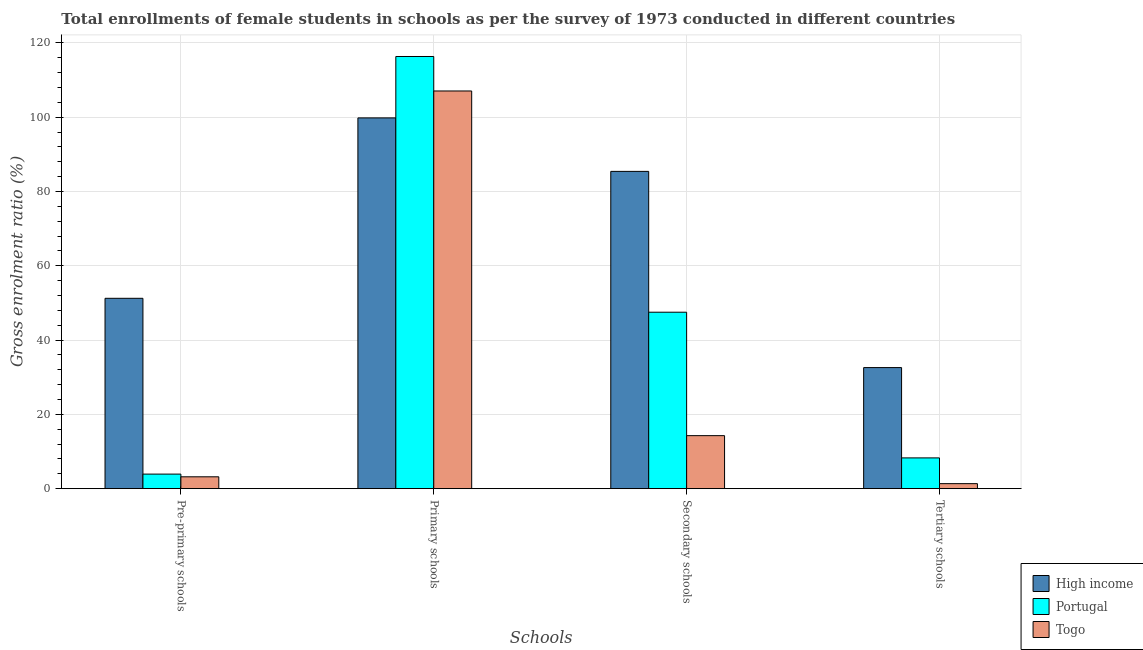How many different coloured bars are there?
Offer a very short reply. 3. Are the number of bars per tick equal to the number of legend labels?
Provide a short and direct response. Yes. Are the number of bars on each tick of the X-axis equal?
Your response must be concise. Yes. How many bars are there on the 2nd tick from the right?
Give a very brief answer. 3. What is the label of the 3rd group of bars from the left?
Ensure brevity in your answer.  Secondary schools. What is the gross enrolment ratio(female) in primary schools in High income?
Ensure brevity in your answer.  99.82. Across all countries, what is the maximum gross enrolment ratio(female) in secondary schools?
Your response must be concise. 85.42. Across all countries, what is the minimum gross enrolment ratio(female) in primary schools?
Your answer should be compact. 99.82. In which country was the gross enrolment ratio(female) in secondary schools maximum?
Offer a terse response. High income. In which country was the gross enrolment ratio(female) in secondary schools minimum?
Offer a terse response. Togo. What is the total gross enrolment ratio(female) in primary schools in the graph?
Your response must be concise. 323.25. What is the difference between the gross enrolment ratio(female) in tertiary schools in High income and that in Portugal?
Your answer should be very brief. 24.32. What is the difference between the gross enrolment ratio(female) in secondary schools in Portugal and the gross enrolment ratio(female) in primary schools in Togo?
Your answer should be compact. -59.56. What is the average gross enrolment ratio(female) in secondary schools per country?
Ensure brevity in your answer.  49.07. What is the difference between the gross enrolment ratio(female) in primary schools and gross enrolment ratio(female) in tertiary schools in High income?
Your answer should be very brief. 67.22. What is the ratio of the gross enrolment ratio(female) in primary schools in Portugal to that in Togo?
Provide a short and direct response. 1.09. What is the difference between the highest and the second highest gross enrolment ratio(female) in tertiary schools?
Provide a short and direct response. 24.32. What is the difference between the highest and the lowest gross enrolment ratio(female) in primary schools?
Offer a very short reply. 16.54. In how many countries, is the gross enrolment ratio(female) in pre-primary schools greater than the average gross enrolment ratio(female) in pre-primary schools taken over all countries?
Your answer should be very brief. 1. What does the 3rd bar from the left in Primary schools represents?
Offer a terse response. Togo. What does the 2nd bar from the right in Primary schools represents?
Your answer should be compact. Portugal. Is it the case that in every country, the sum of the gross enrolment ratio(female) in pre-primary schools and gross enrolment ratio(female) in primary schools is greater than the gross enrolment ratio(female) in secondary schools?
Ensure brevity in your answer.  Yes. How many bars are there?
Your answer should be compact. 12. Are all the bars in the graph horizontal?
Give a very brief answer. No. Are the values on the major ticks of Y-axis written in scientific E-notation?
Your answer should be compact. No. Where does the legend appear in the graph?
Your response must be concise. Bottom right. How many legend labels are there?
Keep it short and to the point. 3. How are the legend labels stacked?
Keep it short and to the point. Vertical. What is the title of the graph?
Provide a short and direct response. Total enrollments of female students in schools as per the survey of 1973 conducted in different countries. What is the label or title of the X-axis?
Ensure brevity in your answer.  Schools. What is the Gross enrolment ratio (%) in High income in Pre-primary schools?
Provide a short and direct response. 51.25. What is the Gross enrolment ratio (%) in Portugal in Pre-primary schools?
Provide a succinct answer. 3.92. What is the Gross enrolment ratio (%) of Togo in Pre-primary schools?
Offer a very short reply. 3.2. What is the Gross enrolment ratio (%) of High income in Primary schools?
Your answer should be compact. 99.82. What is the Gross enrolment ratio (%) of Portugal in Primary schools?
Provide a short and direct response. 116.36. What is the Gross enrolment ratio (%) in Togo in Primary schools?
Your answer should be compact. 107.07. What is the Gross enrolment ratio (%) in High income in Secondary schools?
Offer a terse response. 85.42. What is the Gross enrolment ratio (%) of Portugal in Secondary schools?
Offer a terse response. 47.51. What is the Gross enrolment ratio (%) in Togo in Secondary schools?
Offer a terse response. 14.28. What is the Gross enrolment ratio (%) of High income in Tertiary schools?
Offer a terse response. 32.6. What is the Gross enrolment ratio (%) of Portugal in Tertiary schools?
Offer a very short reply. 8.29. What is the Gross enrolment ratio (%) of Togo in Tertiary schools?
Your response must be concise. 1.35. Across all Schools, what is the maximum Gross enrolment ratio (%) in High income?
Give a very brief answer. 99.82. Across all Schools, what is the maximum Gross enrolment ratio (%) in Portugal?
Make the answer very short. 116.36. Across all Schools, what is the maximum Gross enrolment ratio (%) in Togo?
Provide a short and direct response. 107.07. Across all Schools, what is the minimum Gross enrolment ratio (%) of High income?
Make the answer very short. 32.6. Across all Schools, what is the minimum Gross enrolment ratio (%) of Portugal?
Provide a short and direct response. 3.92. Across all Schools, what is the minimum Gross enrolment ratio (%) in Togo?
Your response must be concise. 1.35. What is the total Gross enrolment ratio (%) of High income in the graph?
Give a very brief answer. 269.1. What is the total Gross enrolment ratio (%) of Portugal in the graph?
Ensure brevity in your answer.  176.08. What is the total Gross enrolment ratio (%) in Togo in the graph?
Your answer should be compact. 125.9. What is the difference between the Gross enrolment ratio (%) in High income in Pre-primary schools and that in Primary schools?
Give a very brief answer. -48.57. What is the difference between the Gross enrolment ratio (%) of Portugal in Pre-primary schools and that in Primary schools?
Your response must be concise. -112.43. What is the difference between the Gross enrolment ratio (%) of Togo in Pre-primary schools and that in Primary schools?
Your answer should be compact. -103.87. What is the difference between the Gross enrolment ratio (%) in High income in Pre-primary schools and that in Secondary schools?
Provide a short and direct response. -34.17. What is the difference between the Gross enrolment ratio (%) of Portugal in Pre-primary schools and that in Secondary schools?
Ensure brevity in your answer.  -43.58. What is the difference between the Gross enrolment ratio (%) of Togo in Pre-primary schools and that in Secondary schools?
Provide a succinct answer. -11.08. What is the difference between the Gross enrolment ratio (%) of High income in Pre-primary schools and that in Tertiary schools?
Keep it short and to the point. 18.65. What is the difference between the Gross enrolment ratio (%) of Portugal in Pre-primary schools and that in Tertiary schools?
Keep it short and to the point. -4.36. What is the difference between the Gross enrolment ratio (%) of Togo in Pre-primary schools and that in Tertiary schools?
Your answer should be compact. 1.84. What is the difference between the Gross enrolment ratio (%) in High income in Primary schools and that in Secondary schools?
Your answer should be compact. 14.4. What is the difference between the Gross enrolment ratio (%) in Portugal in Primary schools and that in Secondary schools?
Offer a terse response. 68.85. What is the difference between the Gross enrolment ratio (%) of Togo in Primary schools and that in Secondary schools?
Offer a terse response. 92.79. What is the difference between the Gross enrolment ratio (%) in High income in Primary schools and that in Tertiary schools?
Provide a short and direct response. 67.22. What is the difference between the Gross enrolment ratio (%) in Portugal in Primary schools and that in Tertiary schools?
Provide a succinct answer. 108.07. What is the difference between the Gross enrolment ratio (%) of Togo in Primary schools and that in Tertiary schools?
Provide a succinct answer. 105.72. What is the difference between the Gross enrolment ratio (%) of High income in Secondary schools and that in Tertiary schools?
Provide a short and direct response. 52.82. What is the difference between the Gross enrolment ratio (%) of Portugal in Secondary schools and that in Tertiary schools?
Keep it short and to the point. 39.22. What is the difference between the Gross enrolment ratio (%) of Togo in Secondary schools and that in Tertiary schools?
Provide a succinct answer. 12.92. What is the difference between the Gross enrolment ratio (%) of High income in Pre-primary schools and the Gross enrolment ratio (%) of Portugal in Primary schools?
Provide a succinct answer. -65.1. What is the difference between the Gross enrolment ratio (%) in High income in Pre-primary schools and the Gross enrolment ratio (%) in Togo in Primary schools?
Keep it short and to the point. -55.82. What is the difference between the Gross enrolment ratio (%) of Portugal in Pre-primary schools and the Gross enrolment ratio (%) of Togo in Primary schools?
Provide a succinct answer. -103.14. What is the difference between the Gross enrolment ratio (%) of High income in Pre-primary schools and the Gross enrolment ratio (%) of Portugal in Secondary schools?
Offer a terse response. 3.74. What is the difference between the Gross enrolment ratio (%) of High income in Pre-primary schools and the Gross enrolment ratio (%) of Togo in Secondary schools?
Your answer should be very brief. 36.97. What is the difference between the Gross enrolment ratio (%) of Portugal in Pre-primary schools and the Gross enrolment ratio (%) of Togo in Secondary schools?
Give a very brief answer. -10.35. What is the difference between the Gross enrolment ratio (%) of High income in Pre-primary schools and the Gross enrolment ratio (%) of Portugal in Tertiary schools?
Provide a succinct answer. 42.97. What is the difference between the Gross enrolment ratio (%) in High income in Pre-primary schools and the Gross enrolment ratio (%) in Togo in Tertiary schools?
Your answer should be compact. 49.9. What is the difference between the Gross enrolment ratio (%) in Portugal in Pre-primary schools and the Gross enrolment ratio (%) in Togo in Tertiary schools?
Offer a very short reply. 2.57. What is the difference between the Gross enrolment ratio (%) in High income in Primary schools and the Gross enrolment ratio (%) in Portugal in Secondary schools?
Offer a very short reply. 52.31. What is the difference between the Gross enrolment ratio (%) of High income in Primary schools and the Gross enrolment ratio (%) of Togo in Secondary schools?
Keep it short and to the point. 85.54. What is the difference between the Gross enrolment ratio (%) in Portugal in Primary schools and the Gross enrolment ratio (%) in Togo in Secondary schools?
Your answer should be very brief. 102.08. What is the difference between the Gross enrolment ratio (%) in High income in Primary schools and the Gross enrolment ratio (%) in Portugal in Tertiary schools?
Your answer should be very brief. 91.54. What is the difference between the Gross enrolment ratio (%) of High income in Primary schools and the Gross enrolment ratio (%) of Togo in Tertiary schools?
Provide a succinct answer. 98.47. What is the difference between the Gross enrolment ratio (%) in Portugal in Primary schools and the Gross enrolment ratio (%) in Togo in Tertiary schools?
Provide a succinct answer. 115. What is the difference between the Gross enrolment ratio (%) of High income in Secondary schools and the Gross enrolment ratio (%) of Portugal in Tertiary schools?
Make the answer very short. 77.14. What is the difference between the Gross enrolment ratio (%) of High income in Secondary schools and the Gross enrolment ratio (%) of Togo in Tertiary schools?
Ensure brevity in your answer.  84.07. What is the difference between the Gross enrolment ratio (%) in Portugal in Secondary schools and the Gross enrolment ratio (%) in Togo in Tertiary schools?
Give a very brief answer. 46.16. What is the average Gross enrolment ratio (%) in High income per Schools?
Give a very brief answer. 67.28. What is the average Gross enrolment ratio (%) of Portugal per Schools?
Your answer should be very brief. 44.02. What is the average Gross enrolment ratio (%) of Togo per Schools?
Provide a short and direct response. 31.48. What is the difference between the Gross enrolment ratio (%) of High income and Gross enrolment ratio (%) of Portugal in Pre-primary schools?
Offer a very short reply. 47.33. What is the difference between the Gross enrolment ratio (%) in High income and Gross enrolment ratio (%) in Togo in Pre-primary schools?
Keep it short and to the point. 48.06. What is the difference between the Gross enrolment ratio (%) in Portugal and Gross enrolment ratio (%) in Togo in Pre-primary schools?
Offer a very short reply. 0.73. What is the difference between the Gross enrolment ratio (%) of High income and Gross enrolment ratio (%) of Portugal in Primary schools?
Keep it short and to the point. -16.54. What is the difference between the Gross enrolment ratio (%) of High income and Gross enrolment ratio (%) of Togo in Primary schools?
Your answer should be compact. -7.25. What is the difference between the Gross enrolment ratio (%) in Portugal and Gross enrolment ratio (%) in Togo in Primary schools?
Your answer should be very brief. 9.29. What is the difference between the Gross enrolment ratio (%) of High income and Gross enrolment ratio (%) of Portugal in Secondary schools?
Make the answer very short. 37.91. What is the difference between the Gross enrolment ratio (%) of High income and Gross enrolment ratio (%) of Togo in Secondary schools?
Provide a succinct answer. 71.15. What is the difference between the Gross enrolment ratio (%) of Portugal and Gross enrolment ratio (%) of Togo in Secondary schools?
Ensure brevity in your answer.  33.23. What is the difference between the Gross enrolment ratio (%) of High income and Gross enrolment ratio (%) of Portugal in Tertiary schools?
Ensure brevity in your answer.  24.32. What is the difference between the Gross enrolment ratio (%) of High income and Gross enrolment ratio (%) of Togo in Tertiary schools?
Offer a terse response. 31.25. What is the difference between the Gross enrolment ratio (%) in Portugal and Gross enrolment ratio (%) in Togo in Tertiary schools?
Keep it short and to the point. 6.93. What is the ratio of the Gross enrolment ratio (%) of High income in Pre-primary schools to that in Primary schools?
Offer a terse response. 0.51. What is the ratio of the Gross enrolment ratio (%) in Portugal in Pre-primary schools to that in Primary schools?
Ensure brevity in your answer.  0.03. What is the ratio of the Gross enrolment ratio (%) in Togo in Pre-primary schools to that in Primary schools?
Your answer should be very brief. 0.03. What is the ratio of the Gross enrolment ratio (%) in Portugal in Pre-primary schools to that in Secondary schools?
Ensure brevity in your answer.  0.08. What is the ratio of the Gross enrolment ratio (%) in Togo in Pre-primary schools to that in Secondary schools?
Offer a terse response. 0.22. What is the ratio of the Gross enrolment ratio (%) in High income in Pre-primary schools to that in Tertiary schools?
Offer a very short reply. 1.57. What is the ratio of the Gross enrolment ratio (%) in Portugal in Pre-primary schools to that in Tertiary schools?
Offer a very short reply. 0.47. What is the ratio of the Gross enrolment ratio (%) of Togo in Pre-primary schools to that in Tertiary schools?
Offer a very short reply. 2.36. What is the ratio of the Gross enrolment ratio (%) in High income in Primary schools to that in Secondary schools?
Make the answer very short. 1.17. What is the ratio of the Gross enrolment ratio (%) in Portugal in Primary schools to that in Secondary schools?
Provide a succinct answer. 2.45. What is the ratio of the Gross enrolment ratio (%) in Togo in Primary schools to that in Secondary schools?
Give a very brief answer. 7.5. What is the ratio of the Gross enrolment ratio (%) of High income in Primary schools to that in Tertiary schools?
Offer a very short reply. 3.06. What is the ratio of the Gross enrolment ratio (%) of Portugal in Primary schools to that in Tertiary schools?
Ensure brevity in your answer.  14.04. What is the ratio of the Gross enrolment ratio (%) of Togo in Primary schools to that in Tertiary schools?
Offer a terse response. 79.08. What is the ratio of the Gross enrolment ratio (%) in High income in Secondary schools to that in Tertiary schools?
Provide a succinct answer. 2.62. What is the ratio of the Gross enrolment ratio (%) in Portugal in Secondary schools to that in Tertiary schools?
Offer a terse response. 5.73. What is the ratio of the Gross enrolment ratio (%) in Togo in Secondary schools to that in Tertiary schools?
Keep it short and to the point. 10.55. What is the difference between the highest and the second highest Gross enrolment ratio (%) of High income?
Give a very brief answer. 14.4. What is the difference between the highest and the second highest Gross enrolment ratio (%) in Portugal?
Keep it short and to the point. 68.85. What is the difference between the highest and the second highest Gross enrolment ratio (%) in Togo?
Offer a very short reply. 92.79. What is the difference between the highest and the lowest Gross enrolment ratio (%) in High income?
Offer a very short reply. 67.22. What is the difference between the highest and the lowest Gross enrolment ratio (%) of Portugal?
Your response must be concise. 112.43. What is the difference between the highest and the lowest Gross enrolment ratio (%) in Togo?
Your answer should be very brief. 105.72. 